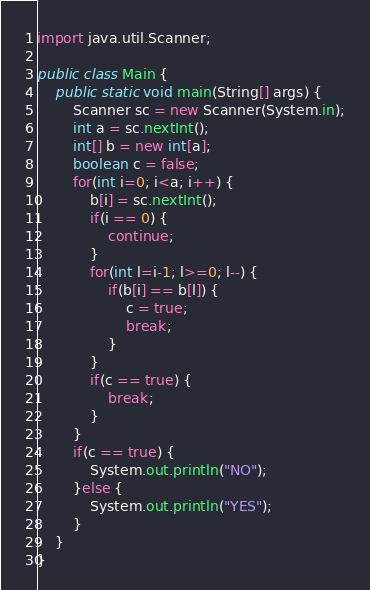Convert code to text. <code><loc_0><loc_0><loc_500><loc_500><_Java_>import java.util.Scanner;

public class Main {
	public static void main(String[] args) {
        Scanner sc = new Scanner(System.in);
        int a = sc.nextInt();
        int[] b = new int[a];
        boolean c = false;
        for(int i=0; i<a; i++) {
        	b[i] = sc.nextInt();
        	if(i == 0) {
        		continue;
        	}
        	for(int l=i-1; l>=0; l--) {
        		if(b[i] == b[l]) {
        			c = true;
        			break;
        		}
        	}
        	if(c == true) {
    			break;
    		}
        }
        if(c == true) {
        	System.out.println("NO");
        }else {
        	System.out.println("YES");
        }
	}
}</code> 